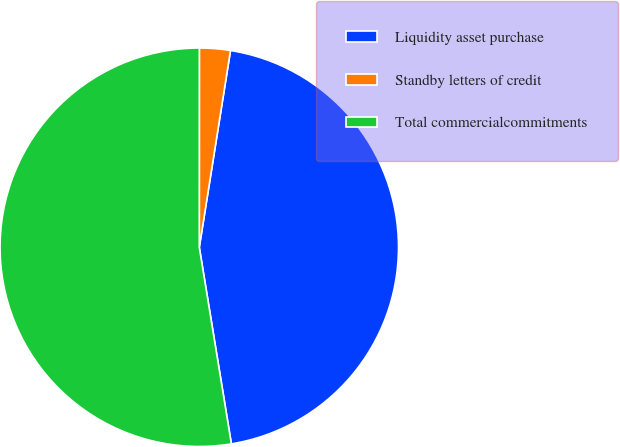Convert chart to OTSL. <chart><loc_0><loc_0><loc_500><loc_500><pie_chart><fcel>Liquidity asset purchase<fcel>Standby letters of credit<fcel>Total commercialcommitments<nl><fcel>44.92%<fcel>2.5%<fcel>52.58%<nl></chart> 